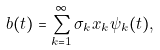<formula> <loc_0><loc_0><loc_500><loc_500>b ( t ) = \sum _ { k = 1 } ^ { \infty } \sigma _ { k } x _ { k } \psi _ { k } ( t ) ,</formula> 